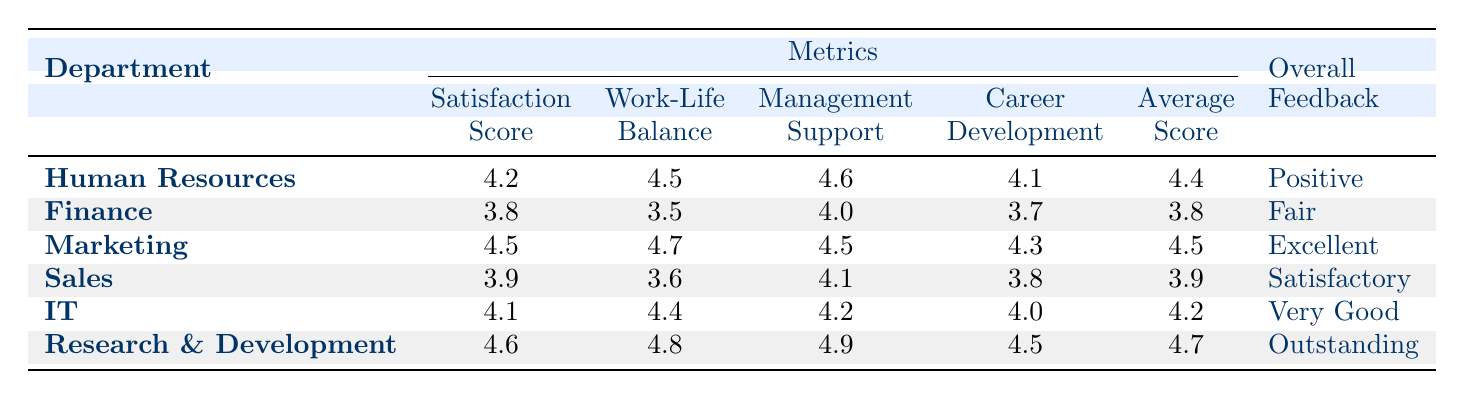What is the Satisfaction Score for the Marketing department? The table shows the Satisfaction Score for each department. For Marketing, the corresponding value is directly provided in the table as 4.5.
Answer: 4.5 Which department has the highest Management Support score? By examining the Management Support scores for all departments, Research and Development has the highest score of 4.9, as indicated in the table.
Answer: Research and Development What is the average Work-Life Balance score across all departments? To find the average, sum the Work-Life Balance scores: 4.5 (HR) + 3.5 (Finance) + 4.7 (Marketing) + 3.6 (Sales) + 4.4 (IT) + 4.8 (R&D) = 25.5. There are 6 departments, so the average is 25.5 / 6 = 4.25.
Answer: 4.25 Is the Overall Feedback for the IT department considered Fair? The Overall Feedback for the IT department is listed as "Very Good" in the table, which does not match the term "Fair." Therefore, the statement is false.
Answer: No Which department has a Career Development Opportunities score below 4.0? By checking the Career Development Opportunities scores, the Finance department has a score of 3.7, which is below 4.0, while all other departments have scores at or above 4.0.
Answer: Finance What is the difference in the Satisfaction Scores between the highest and lowest departments? Research and Development has the highest Satisfaction Score of 4.6, and Finance has the lowest, with a score of 3.8. The difference is 4.6 - 3.8 = 0.8.
Answer: 0.8 What Overall Feedback did the Finance department receive? The table lists the Overall Feedback for the Finance department as "Fair." This information can be directly found in the table under the corresponding department.
Answer: Fair Which two departments have a Work-Life Balance score of 4.5 or above? By reviewing the Work-Life Balance scores, Human Resources (4.5) and Research and Development (4.8) both have scores of 4.5 or higher. These departments meet the criteria specified.
Answer: Human Resources, Research and Development What is the average Career Development Opportunities score for the departments with an Overall Feedback of "Positive" or better? The departments with "Positive" or better feedback are Human Resources (4.1), Marketing (4.3), IT (4.0), and Research and Development (4.5). Summing their scores gives: 4.1 + 4.3 + 4.0 + 4.5 = 16.9. The average is 16.9 / 4 = 4.225.
Answer: 4.225 